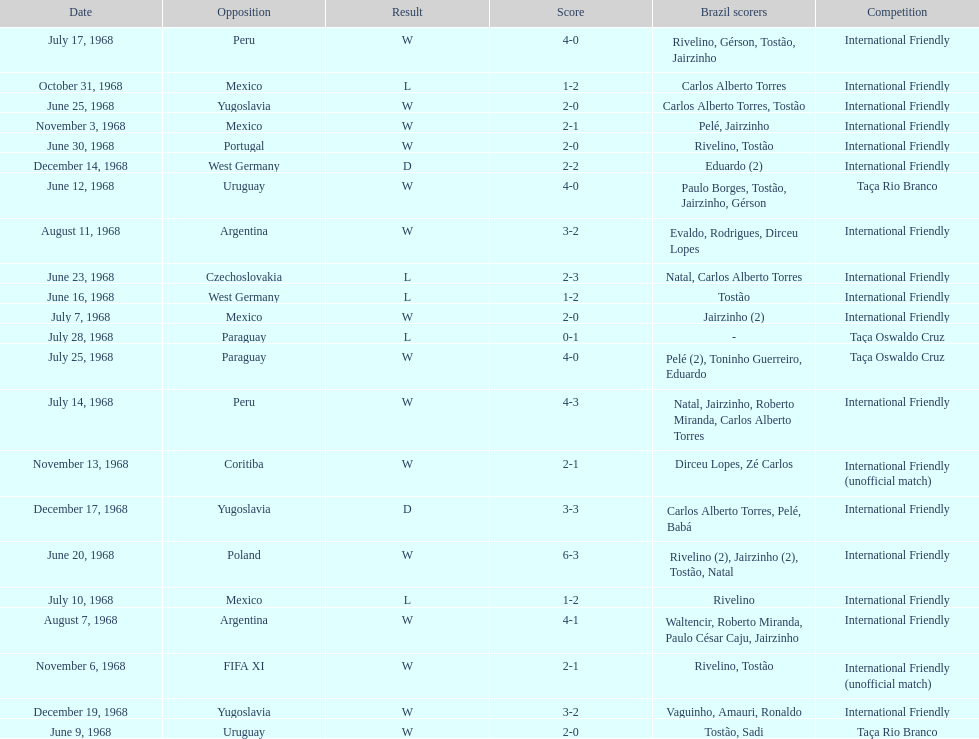In which year did the highest-scoring game take place? 1968. 